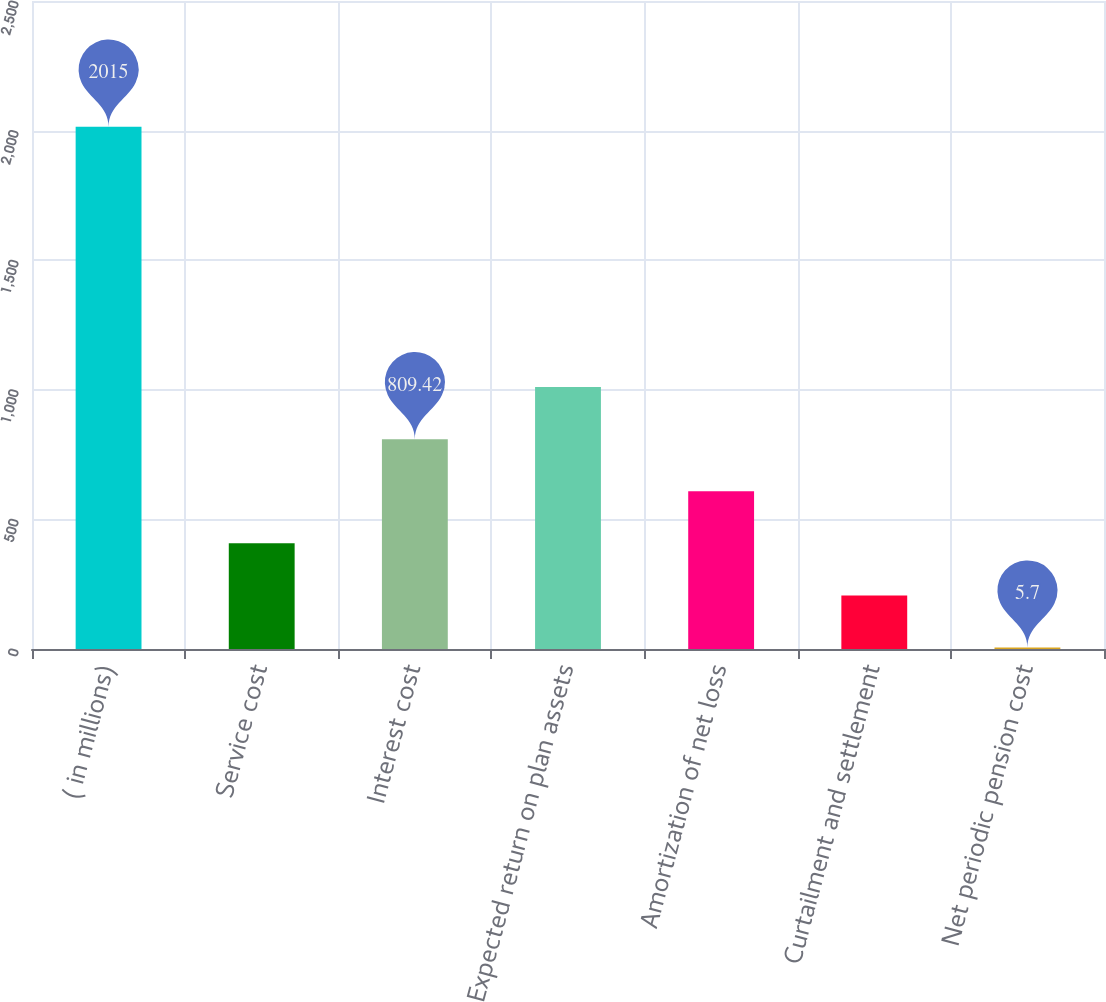<chart> <loc_0><loc_0><loc_500><loc_500><bar_chart><fcel>( in millions)<fcel>Service cost<fcel>Interest cost<fcel>Expected return on plan assets<fcel>Amortization of net loss<fcel>Curtailment and settlement<fcel>Net periodic pension cost<nl><fcel>2015<fcel>407.56<fcel>809.42<fcel>1010.35<fcel>608.49<fcel>206.63<fcel>5.7<nl></chart> 